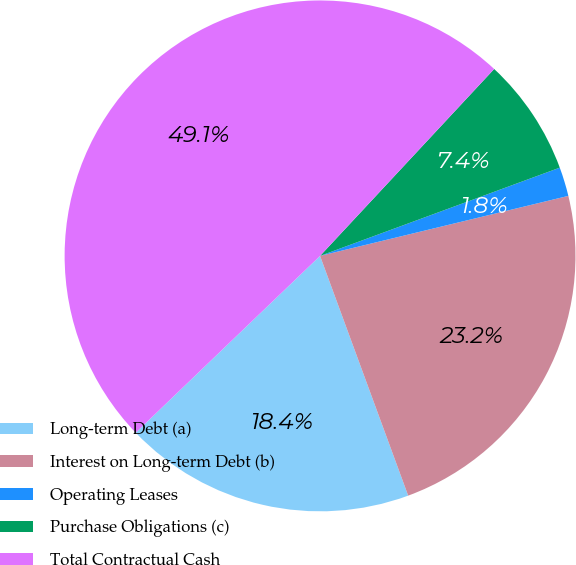Convert chart. <chart><loc_0><loc_0><loc_500><loc_500><pie_chart><fcel>Long-term Debt (a)<fcel>Interest on Long-term Debt (b)<fcel>Operating Leases<fcel>Purchase Obligations (c)<fcel>Total Contractual Cash<nl><fcel>18.44%<fcel>23.17%<fcel>1.84%<fcel>7.45%<fcel>49.11%<nl></chart> 